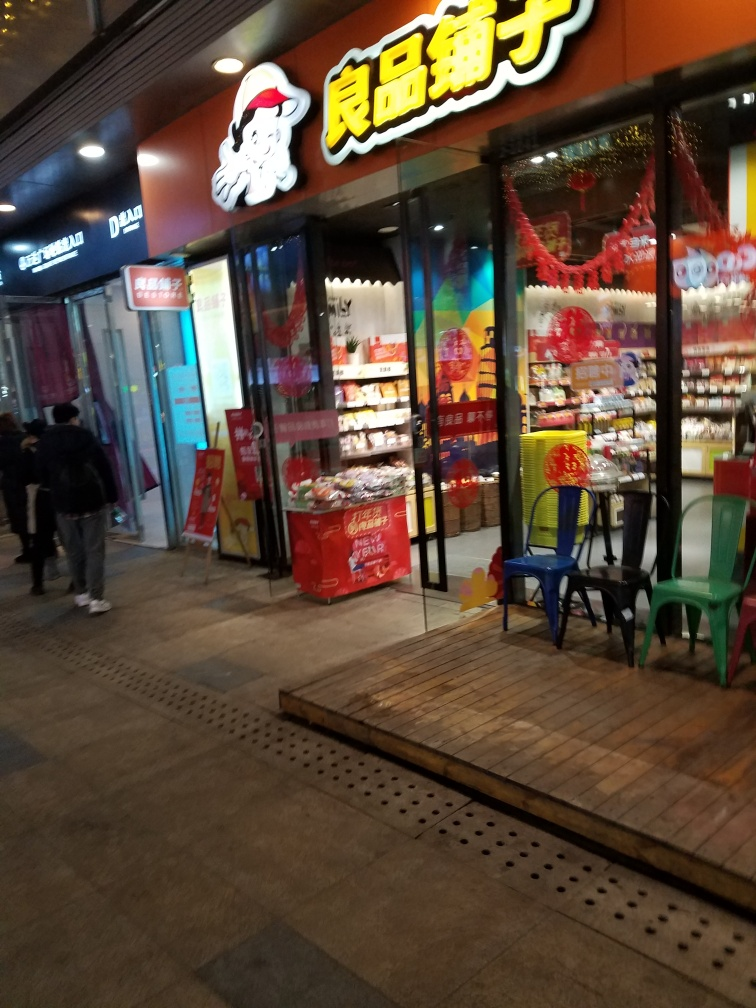Is the white balance accurate in the photo? The white balance in the photo appears to be slightly off, as the image has an overall warm tone, possibly caused by artificial lighting conditions inside the store and nearby street lights. This can affect the appearance of colors, making them different than they would appear under natural daylight conditions. 